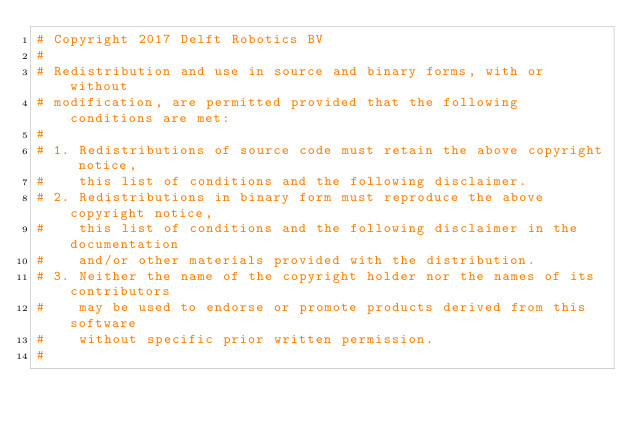<code> <loc_0><loc_0><loc_500><loc_500><_Python_># Copyright 2017 Delft Robotics BV
#
# Redistribution and use in source and binary forms, with or without
# modification, are permitted provided that the following conditions are met:
#
# 1. Redistributions of source code must retain the above copyright notice,
#    this list of conditions and the following disclaimer.
# 2. Redistributions in binary form must reproduce the above copyright notice,
#    this list of conditions and the following disclaimer in the documentation
#    and/or other materials provided with the distribution.
# 3. Neither the name of the copyright holder nor the names of its contributors
#    may be used to endorse or promote products derived from this software
#    without specific prior written permission.
#</code> 